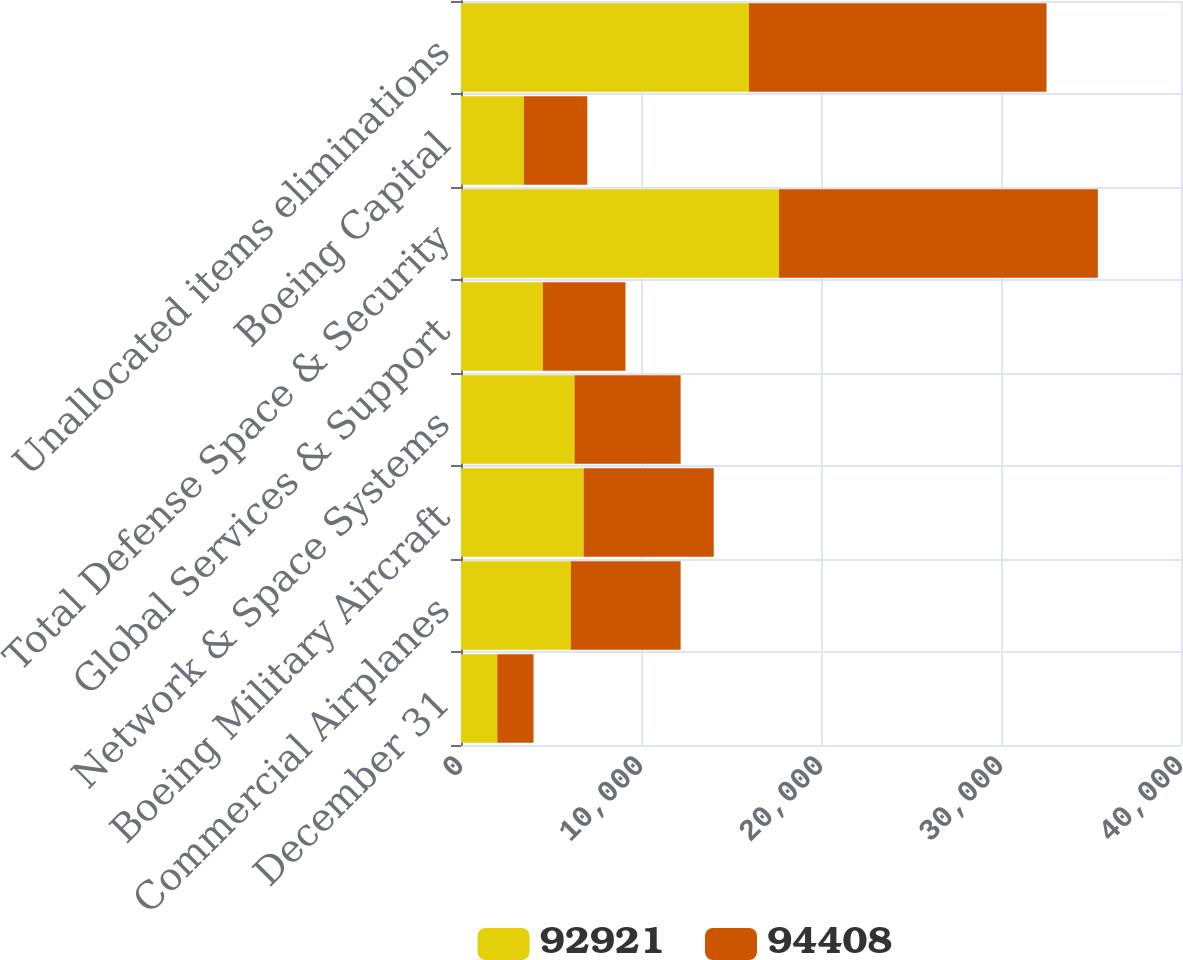Convert chart. <chart><loc_0><loc_0><loc_500><loc_500><stacked_bar_chart><ecel><fcel>December 31<fcel>Commercial Airplanes<fcel>Boeing Military Aircraft<fcel>Network & Space Systems<fcel>Global Services & Support<fcel>Total Defense Space & Security<fcel>Boeing Capital<fcel>Unallocated items eliminations<nl><fcel>92921<fcel>2015<fcel>6101<fcel>6811<fcel>6307<fcel>4549<fcel>17667<fcel>3492<fcel>15996<nl><fcel>94408<fcel>2014<fcel>6101<fcel>7229<fcel>5895<fcel>4589<fcel>17713<fcel>3525<fcel>16534<nl></chart> 